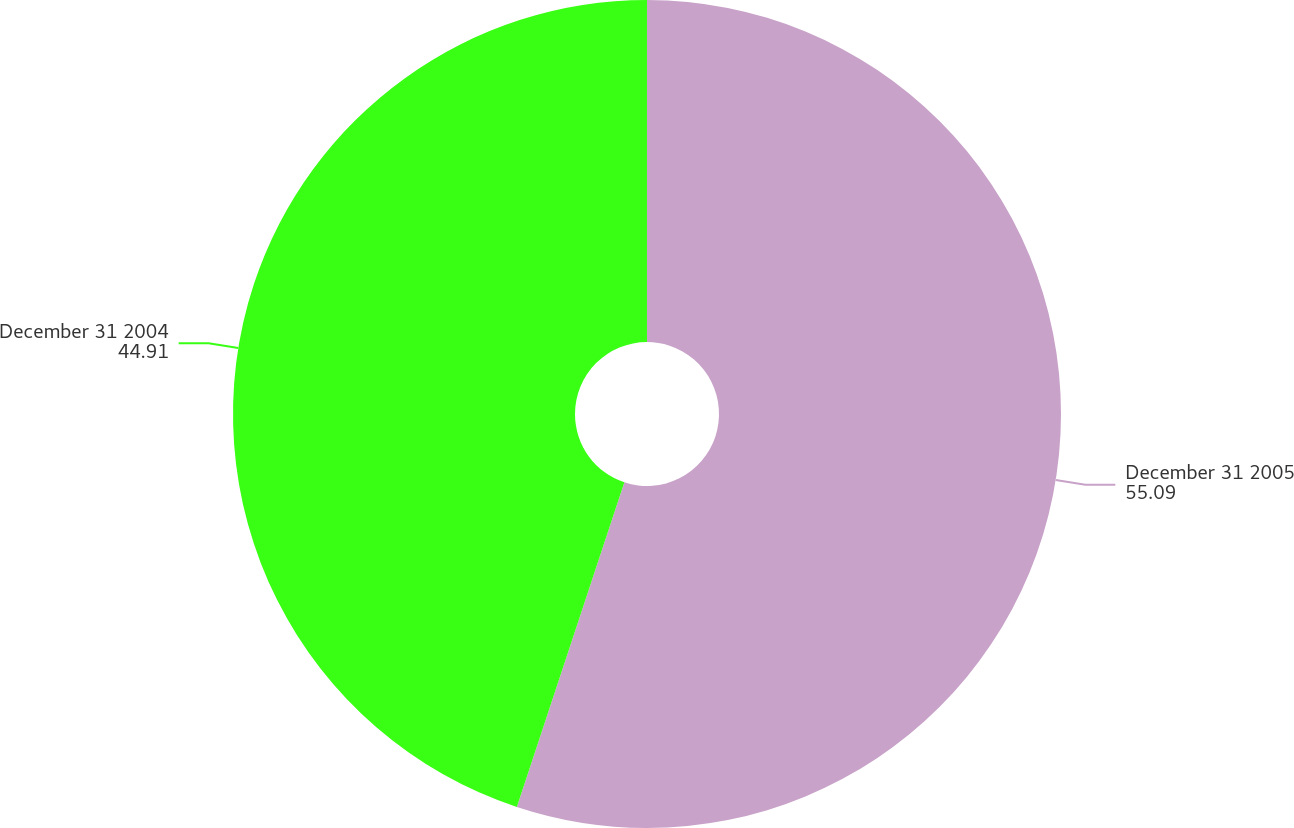Convert chart to OTSL. <chart><loc_0><loc_0><loc_500><loc_500><pie_chart><fcel>December 31 2005<fcel>December 31 2004<nl><fcel>55.09%<fcel>44.91%<nl></chart> 